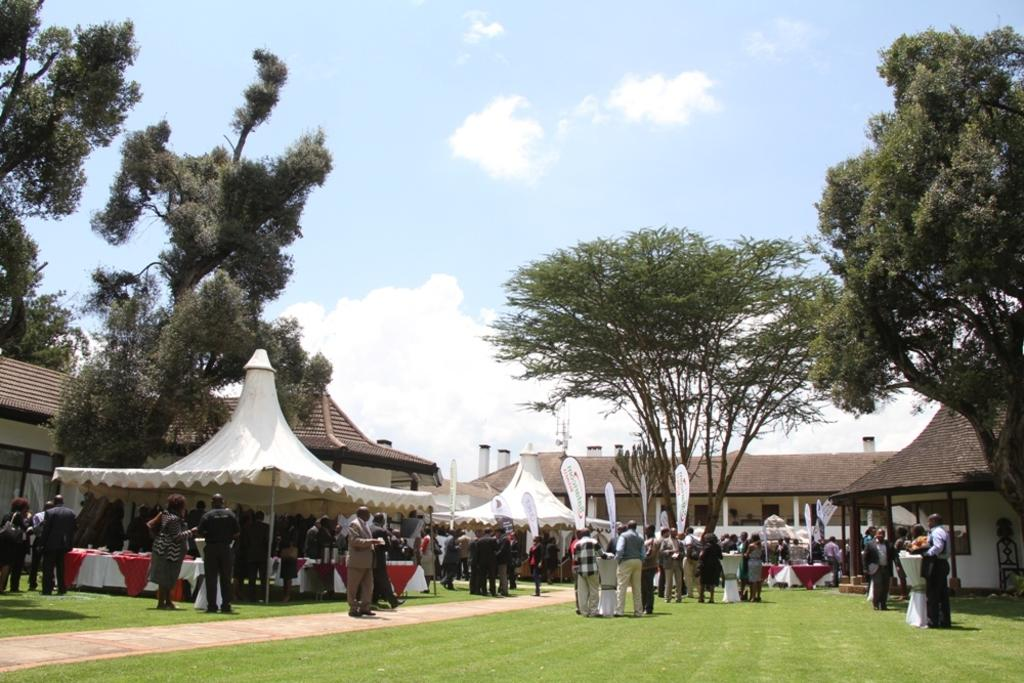What can be seen at the bottom of the image? There are people at the bottom side of the image. What type of vegetation is present on the right side of the image? There are trees on the right side of the image. What type of vegetation is present on the left side of the image? There are trees on the left side of the image. What type of structures are located in the center of the image? There are houses in the center of the image. What is the level of disgust expressed by the people in the image? There is no indication of any emotion, including disgust, in the image. How does the acoustics of the houses in the center of the image affect the sound quality? The image does not provide any information about the acoustics of the houses or the sound quality. 